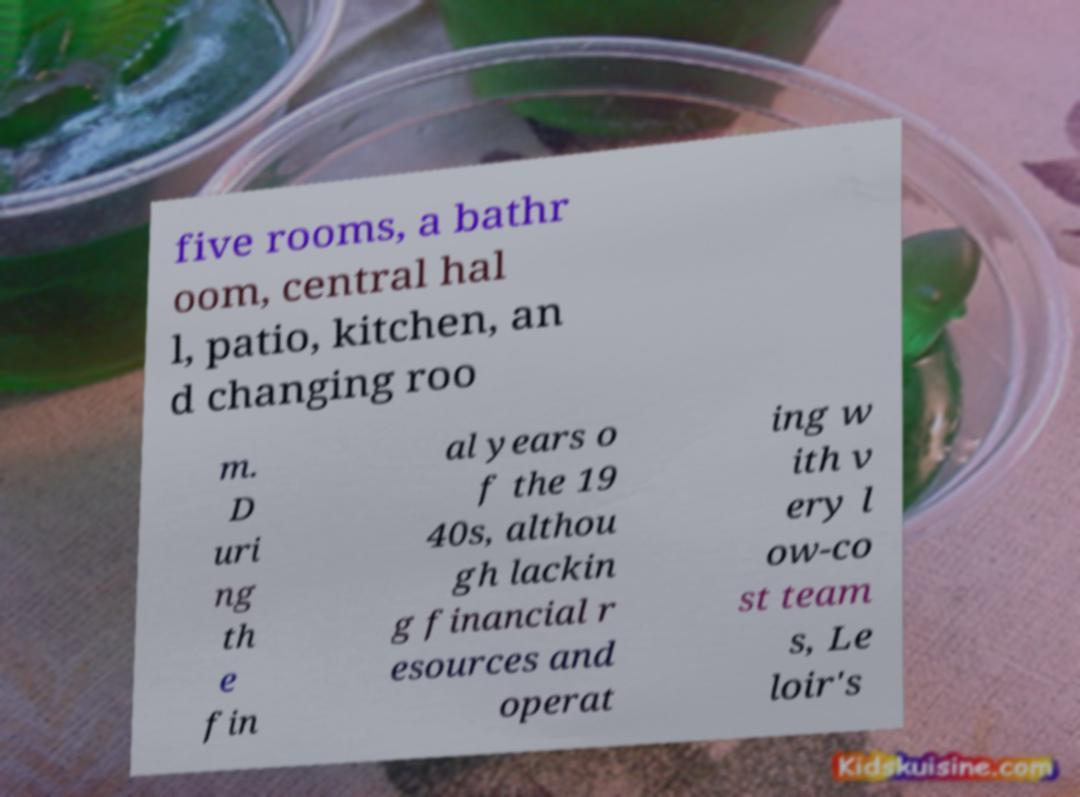For documentation purposes, I need the text within this image transcribed. Could you provide that? five rooms, a bathr oom, central hal l, patio, kitchen, an d changing roo m. D uri ng th e fin al years o f the 19 40s, althou gh lackin g financial r esources and operat ing w ith v ery l ow-co st team s, Le loir's 